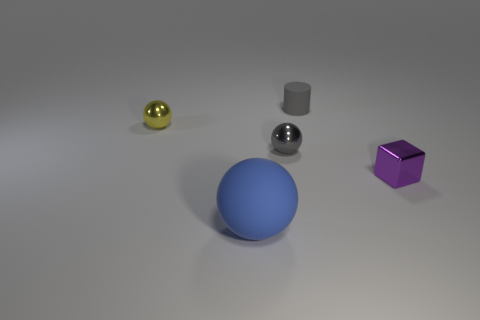What number of other things are the same size as the rubber cylinder?
Your response must be concise. 3. There is a thing on the left side of the matte ball; is it the same shape as the big blue object?
Ensure brevity in your answer.  Yes. Are there more small gray balls that are behind the small purple shiny thing than large green rubber things?
Give a very brief answer. Yes. The thing that is on the right side of the large blue thing and in front of the tiny gray metal sphere is made of what material?
Provide a short and direct response. Metal. Is there anything else that has the same shape as the purple metal object?
Your answer should be very brief. No. How many metal objects are to the left of the big blue object and in front of the tiny gray ball?
Give a very brief answer. 0. What material is the purple cube?
Keep it short and to the point. Metal. Are there the same number of tiny yellow shiny balls that are behind the tiny yellow metal sphere and blue rubber spheres?
Give a very brief answer. No. What number of other tiny things have the same shape as the yellow metallic object?
Ensure brevity in your answer.  1. Is the yellow shiny object the same shape as the tiny gray shiny thing?
Provide a short and direct response. Yes. 